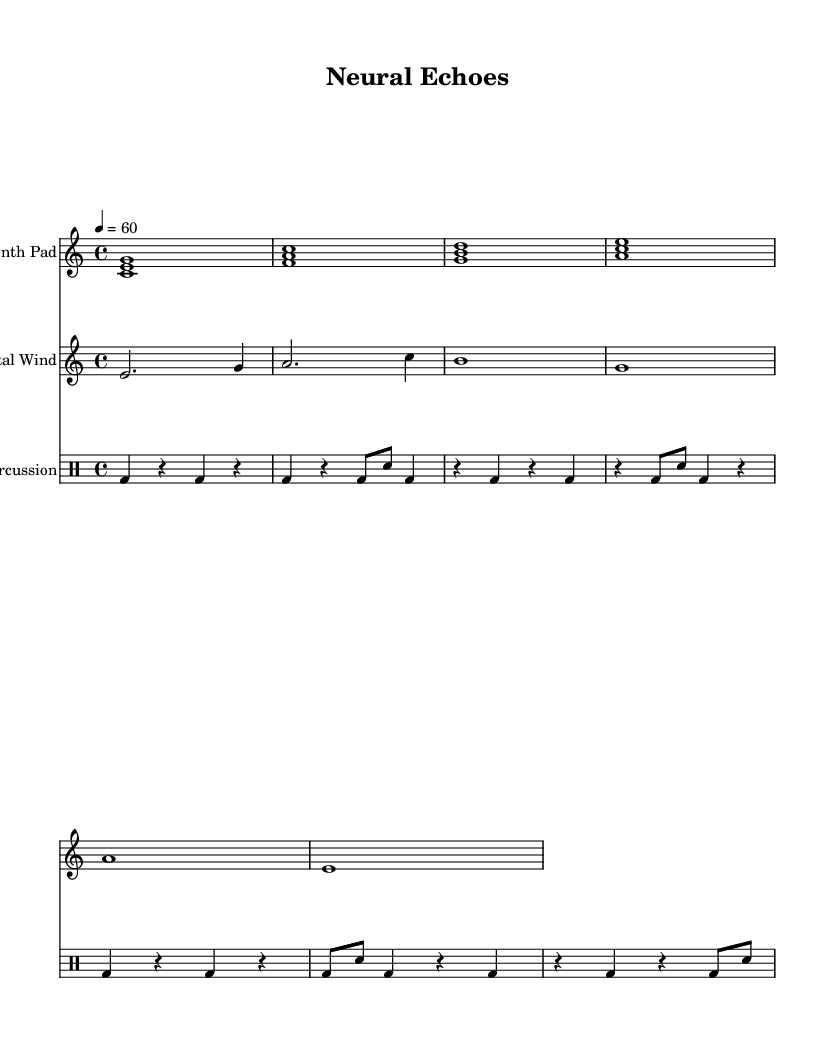What is the key signature of this music? The key signature indicated is C major, which is shown at the beginning of the staff with no sharps or flats.
Answer: C major What is the time signature of this music? The time signature is 4/4, which is specified at the beginning of the piece and generally indicates four beats per measure.
Answer: 4/4 What is the tempo marking for this piece? The tempo marking is indicated as "4 = 60," meaning there are 60 beats per minute, which is a moderately slow tempo.
Answer: 60 How many parts are there in this composition? There are three distinct parts: one for the synth pad, one for the digital wind, and one for electronic percussion, each represented by a separate staff.
Answer: Three What type of instrument is used for the synth pad? The synth pad is specifically indicated in the header of that staff as the instrument name, which denotes that it is intended for a synthesizer sound.
Answer: Synth Pad What rhythmic pattern does the electronic percussion follow? The electronic percussion is comprised of a repeating pattern that alternates between bass drum hits and snare hits, characterized by quarter notes and eighth notes throughout the measure.
Answer: Alternating bass and snare Which sound is represented by "digital wind"? The digital wind refers to the melodic line created in the treble clef, which uses sustained notes and varied durations to mimic wind-like soundscapes, key to ambient music.
Answer: Wind sound 